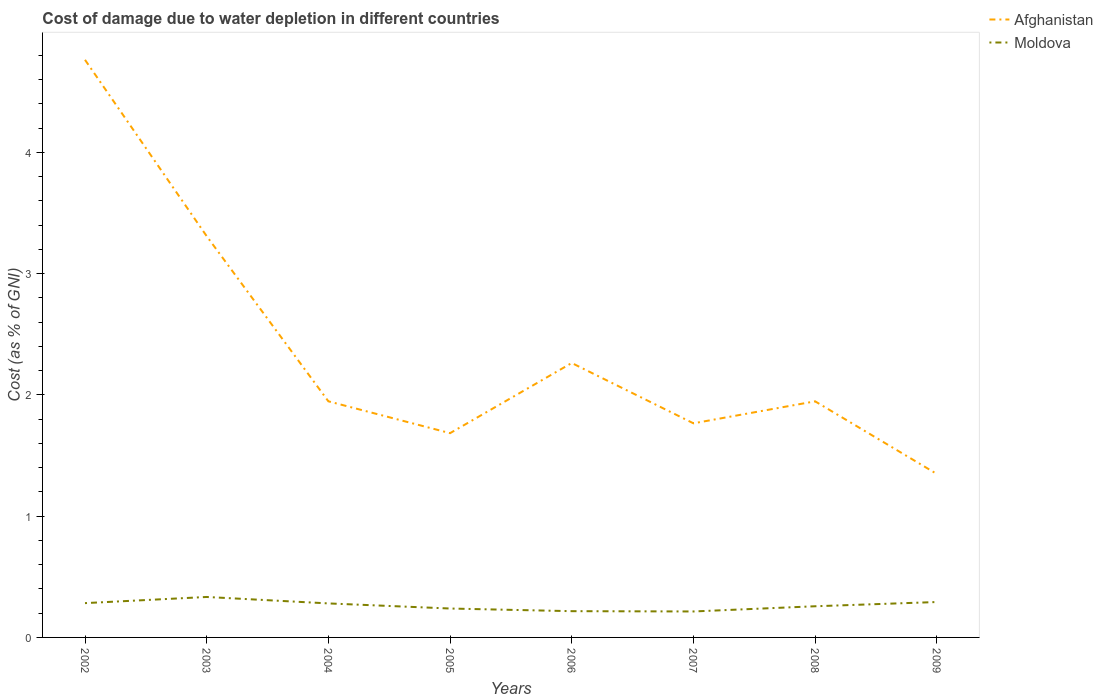Across all years, what is the maximum cost of damage caused due to water depletion in Afghanistan?
Keep it short and to the point. 1.35. What is the total cost of damage caused due to water depletion in Moldova in the graph?
Your answer should be compact. -0.05. What is the difference between the highest and the second highest cost of damage caused due to water depletion in Afghanistan?
Offer a terse response. 3.42. How many years are there in the graph?
Your response must be concise. 8. How many legend labels are there?
Your answer should be compact. 2. How are the legend labels stacked?
Provide a succinct answer. Vertical. What is the title of the graph?
Give a very brief answer. Cost of damage due to water depletion in different countries. Does "Malawi" appear as one of the legend labels in the graph?
Make the answer very short. No. What is the label or title of the Y-axis?
Your answer should be very brief. Cost (as % of GNI). What is the Cost (as % of GNI) of Afghanistan in 2002?
Keep it short and to the point. 4.76. What is the Cost (as % of GNI) in Moldova in 2002?
Offer a very short reply. 0.28. What is the Cost (as % of GNI) of Afghanistan in 2003?
Offer a very short reply. 3.31. What is the Cost (as % of GNI) of Moldova in 2003?
Give a very brief answer. 0.33. What is the Cost (as % of GNI) in Afghanistan in 2004?
Give a very brief answer. 1.95. What is the Cost (as % of GNI) of Moldova in 2004?
Your answer should be compact. 0.28. What is the Cost (as % of GNI) in Afghanistan in 2005?
Your answer should be very brief. 1.68. What is the Cost (as % of GNI) of Moldova in 2005?
Keep it short and to the point. 0.24. What is the Cost (as % of GNI) in Afghanistan in 2006?
Provide a short and direct response. 2.26. What is the Cost (as % of GNI) in Moldova in 2006?
Provide a short and direct response. 0.22. What is the Cost (as % of GNI) of Afghanistan in 2007?
Provide a succinct answer. 1.77. What is the Cost (as % of GNI) of Moldova in 2007?
Ensure brevity in your answer.  0.21. What is the Cost (as % of GNI) in Afghanistan in 2008?
Keep it short and to the point. 1.95. What is the Cost (as % of GNI) in Moldova in 2008?
Offer a very short reply. 0.26. What is the Cost (as % of GNI) of Afghanistan in 2009?
Ensure brevity in your answer.  1.35. What is the Cost (as % of GNI) of Moldova in 2009?
Ensure brevity in your answer.  0.29. Across all years, what is the maximum Cost (as % of GNI) of Afghanistan?
Ensure brevity in your answer.  4.76. Across all years, what is the maximum Cost (as % of GNI) in Moldova?
Ensure brevity in your answer.  0.33. Across all years, what is the minimum Cost (as % of GNI) in Afghanistan?
Give a very brief answer. 1.35. Across all years, what is the minimum Cost (as % of GNI) of Moldova?
Your response must be concise. 0.21. What is the total Cost (as % of GNI) of Afghanistan in the graph?
Make the answer very short. 19.03. What is the total Cost (as % of GNI) of Moldova in the graph?
Make the answer very short. 2.11. What is the difference between the Cost (as % of GNI) of Afghanistan in 2002 and that in 2003?
Make the answer very short. 1.45. What is the difference between the Cost (as % of GNI) in Moldova in 2002 and that in 2003?
Give a very brief answer. -0.05. What is the difference between the Cost (as % of GNI) in Afghanistan in 2002 and that in 2004?
Offer a terse response. 2.82. What is the difference between the Cost (as % of GNI) of Moldova in 2002 and that in 2004?
Provide a short and direct response. 0. What is the difference between the Cost (as % of GNI) of Afghanistan in 2002 and that in 2005?
Provide a short and direct response. 3.08. What is the difference between the Cost (as % of GNI) of Moldova in 2002 and that in 2005?
Ensure brevity in your answer.  0.04. What is the difference between the Cost (as % of GNI) in Afghanistan in 2002 and that in 2006?
Keep it short and to the point. 2.5. What is the difference between the Cost (as % of GNI) in Moldova in 2002 and that in 2006?
Your answer should be compact. 0.07. What is the difference between the Cost (as % of GNI) in Afghanistan in 2002 and that in 2007?
Your answer should be very brief. 3. What is the difference between the Cost (as % of GNI) in Moldova in 2002 and that in 2007?
Provide a short and direct response. 0.07. What is the difference between the Cost (as % of GNI) in Afghanistan in 2002 and that in 2008?
Make the answer very short. 2.82. What is the difference between the Cost (as % of GNI) in Moldova in 2002 and that in 2008?
Offer a very short reply. 0.03. What is the difference between the Cost (as % of GNI) of Afghanistan in 2002 and that in 2009?
Your answer should be compact. 3.42. What is the difference between the Cost (as % of GNI) of Moldova in 2002 and that in 2009?
Provide a short and direct response. -0.01. What is the difference between the Cost (as % of GNI) of Afghanistan in 2003 and that in 2004?
Offer a terse response. 1.36. What is the difference between the Cost (as % of GNI) of Moldova in 2003 and that in 2004?
Your response must be concise. 0.05. What is the difference between the Cost (as % of GNI) of Afghanistan in 2003 and that in 2005?
Your answer should be very brief. 1.62. What is the difference between the Cost (as % of GNI) in Moldova in 2003 and that in 2005?
Your answer should be compact. 0.1. What is the difference between the Cost (as % of GNI) of Afghanistan in 2003 and that in 2006?
Provide a succinct answer. 1.05. What is the difference between the Cost (as % of GNI) of Moldova in 2003 and that in 2006?
Your answer should be very brief. 0.12. What is the difference between the Cost (as % of GNI) of Afghanistan in 2003 and that in 2007?
Offer a terse response. 1.54. What is the difference between the Cost (as % of GNI) in Moldova in 2003 and that in 2007?
Provide a succinct answer. 0.12. What is the difference between the Cost (as % of GNI) in Afghanistan in 2003 and that in 2008?
Keep it short and to the point. 1.36. What is the difference between the Cost (as % of GNI) in Moldova in 2003 and that in 2008?
Your answer should be compact. 0.08. What is the difference between the Cost (as % of GNI) in Afghanistan in 2003 and that in 2009?
Ensure brevity in your answer.  1.96. What is the difference between the Cost (as % of GNI) of Moldova in 2003 and that in 2009?
Offer a terse response. 0.04. What is the difference between the Cost (as % of GNI) of Afghanistan in 2004 and that in 2005?
Keep it short and to the point. 0.26. What is the difference between the Cost (as % of GNI) in Moldova in 2004 and that in 2005?
Your response must be concise. 0.04. What is the difference between the Cost (as % of GNI) in Afghanistan in 2004 and that in 2006?
Keep it short and to the point. -0.32. What is the difference between the Cost (as % of GNI) of Moldova in 2004 and that in 2006?
Provide a short and direct response. 0.06. What is the difference between the Cost (as % of GNI) in Afghanistan in 2004 and that in 2007?
Ensure brevity in your answer.  0.18. What is the difference between the Cost (as % of GNI) of Moldova in 2004 and that in 2007?
Ensure brevity in your answer.  0.07. What is the difference between the Cost (as % of GNI) in Afghanistan in 2004 and that in 2008?
Offer a terse response. 0. What is the difference between the Cost (as % of GNI) of Moldova in 2004 and that in 2008?
Provide a succinct answer. 0.02. What is the difference between the Cost (as % of GNI) in Afghanistan in 2004 and that in 2009?
Give a very brief answer. 0.6. What is the difference between the Cost (as % of GNI) in Moldova in 2004 and that in 2009?
Provide a short and direct response. -0.01. What is the difference between the Cost (as % of GNI) of Afghanistan in 2005 and that in 2006?
Make the answer very short. -0.58. What is the difference between the Cost (as % of GNI) in Moldova in 2005 and that in 2006?
Give a very brief answer. 0.02. What is the difference between the Cost (as % of GNI) of Afghanistan in 2005 and that in 2007?
Provide a short and direct response. -0.08. What is the difference between the Cost (as % of GNI) of Moldova in 2005 and that in 2007?
Keep it short and to the point. 0.02. What is the difference between the Cost (as % of GNI) in Afghanistan in 2005 and that in 2008?
Ensure brevity in your answer.  -0.26. What is the difference between the Cost (as % of GNI) in Moldova in 2005 and that in 2008?
Your answer should be very brief. -0.02. What is the difference between the Cost (as % of GNI) in Afghanistan in 2005 and that in 2009?
Offer a terse response. 0.34. What is the difference between the Cost (as % of GNI) in Moldova in 2005 and that in 2009?
Your answer should be very brief. -0.05. What is the difference between the Cost (as % of GNI) in Afghanistan in 2006 and that in 2007?
Your answer should be compact. 0.5. What is the difference between the Cost (as % of GNI) in Moldova in 2006 and that in 2007?
Your answer should be compact. 0. What is the difference between the Cost (as % of GNI) of Afghanistan in 2006 and that in 2008?
Offer a very short reply. 0.32. What is the difference between the Cost (as % of GNI) in Moldova in 2006 and that in 2008?
Your response must be concise. -0.04. What is the difference between the Cost (as % of GNI) in Afghanistan in 2006 and that in 2009?
Make the answer very short. 0.92. What is the difference between the Cost (as % of GNI) of Moldova in 2006 and that in 2009?
Provide a short and direct response. -0.08. What is the difference between the Cost (as % of GNI) of Afghanistan in 2007 and that in 2008?
Give a very brief answer. -0.18. What is the difference between the Cost (as % of GNI) of Moldova in 2007 and that in 2008?
Your answer should be very brief. -0.04. What is the difference between the Cost (as % of GNI) in Afghanistan in 2007 and that in 2009?
Provide a succinct answer. 0.42. What is the difference between the Cost (as % of GNI) in Moldova in 2007 and that in 2009?
Your answer should be very brief. -0.08. What is the difference between the Cost (as % of GNI) of Afghanistan in 2008 and that in 2009?
Ensure brevity in your answer.  0.6. What is the difference between the Cost (as % of GNI) in Moldova in 2008 and that in 2009?
Your answer should be very brief. -0.03. What is the difference between the Cost (as % of GNI) of Afghanistan in 2002 and the Cost (as % of GNI) of Moldova in 2003?
Ensure brevity in your answer.  4.43. What is the difference between the Cost (as % of GNI) in Afghanistan in 2002 and the Cost (as % of GNI) in Moldova in 2004?
Make the answer very short. 4.48. What is the difference between the Cost (as % of GNI) of Afghanistan in 2002 and the Cost (as % of GNI) of Moldova in 2005?
Keep it short and to the point. 4.52. What is the difference between the Cost (as % of GNI) in Afghanistan in 2002 and the Cost (as % of GNI) in Moldova in 2006?
Provide a succinct answer. 4.55. What is the difference between the Cost (as % of GNI) in Afghanistan in 2002 and the Cost (as % of GNI) in Moldova in 2007?
Provide a succinct answer. 4.55. What is the difference between the Cost (as % of GNI) in Afghanistan in 2002 and the Cost (as % of GNI) in Moldova in 2008?
Keep it short and to the point. 4.51. What is the difference between the Cost (as % of GNI) in Afghanistan in 2002 and the Cost (as % of GNI) in Moldova in 2009?
Offer a very short reply. 4.47. What is the difference between the Cost (as % of GNI) of Afghanistan in 2003 and the Cost (as % of GNI) of Moldova in 2004?
Give a very brief answer. 3.03. What is the difference between the Cost (as % of GNI) of Afghanistan in 2003 and the Cost (as % of GNI) of Moldova in 2005?
Offer a very short reply. 3.07. What is the difference between the Cost (as % of GNI) of Afghanistan in 2003 and the Cost (as % of GNI) of Moldova in 2006?
Your answer should be compact. 3.09. What is the difference between the Cost (as % of GNI) in Afghanistan in 2003 and the Cost (as % of GNI) in Moldova in 2007?
Provide a short and direct response. 3.09. What is the difference between the Cost (as % of GNI) of Afghanistan in 2003 and the Cost (as % of GNI) of Moldova in 2008?
Give a very brief answer. 3.05. What is the difference between the Cost (as % of GNI) of Afghanistan in 2003 and the Cost (as % of GNI) of Moldova in 2009?
Provide a short and direct response. 3.02. What is the difference between the Cost (as % of GNI) of Afghanistan in 2004 and the Cost (as % of GNI) of Moldova in 2005?
Your answer should be compact. 1.71. What is the difference between the Cost (as % of GNI) in Afghanistan in 2004 and the Cost (as % of GNI) in Moldova in 2006?
Keep it short and to the point. 1.73. What is the difference between the Cost (as % of GNI) in Afghanistan in 2004 and the Cost (as % of GNI) in Moldova in 2007?
Your response must be concise. 1.73. What is the difference between the Cost (as % of GNI) of Afghanistan in 2004 and the Cost (as % of GNI) of Moldova in 2008?
Your response must be concise. 1.69. What is the difference between the Cost (as % of GNI) in Afghanistan in 2004 and the Cost (as % of GNI) in Moldova in 2009?
Give a very brief answer. 1.66. What is the difference between the Cost (as % of GNI) of Afghanistan in 2005 and the Cost (as % of GNI) of Moldova in 2006?
Your answer should be compact. 1.47. What is the difference between the Cost (as % of GNI) in Afghanistan in 2005 and the Cost (as % of GNI) in Moldova in 2007?
Provide a short and direct response. 1.47. What is the difference between the Cost (as % of GNI) in Afghanistan in 2005 and the Cost (as % of GNI) in Moldova in 2008?
Offer a very short reply. 1.43. What is the difference between the Cost (as % of GNI) in Afghanistan in 2005 and the Cost (as % of GNI) in Moldova in 2009?
Provide a short and direct response. 1.39. What is the difference between the Cost (as % of GNI) of Afghanistan in 2006 and the Cost (as % of GNI) of Moldova in 2007?
Make the answer very short. 2.05. What is the difference between the Cost (as % of GNI) of Afghanistan in 2006 and the Cost (as % of GNI) of Moldova in 2008?
Make the answer very short. 2.01. What is the difference between the Cost (as % of GNI) of Afghanistan in 2006 and the Cost (as % of GNI) of Moldova in 2009?
Provide a succinct answer. 1.97. What is the difference between the Cost (as % of GNI) of Afghanistan in 2007 and the Cost (as % of GNI) of Moldova in 2008?
Your response must be concise. 1.51. What is the difference between the Cost (as % of GNI) of Afghanistan in 2007 and the Cost (as % of GNI) of Moldova in 2009?
Your answer should be compact. 1.47. What is the difference between the Cost (as % of GNI) of Afghanistan in 2008 and the Cost (as % of GNI) of Moldova in 2009?
Ensure brevity in your answer.  1.66. What is the average Cost (as % of GNI) in Afghanistan per year?
Make the answer very short. 2.38. What is the average Cost (as % of GNI) in Moldova per year?
Provide a succinct answer. 0.26. In the year 2002, what is the difference between the Cost (as % of GNI) in Afghanistan and Cost (as % of GNI) in Moldova?
Your answer should be compact. 4.48. In the year 2003, what is the difference between the Cost (as % of GNI) in Afghanistan and Cost (as % of GNI) in Moldova?
Your answer should be very brief. 2.98. In the year 2004, what is the difference between the Cost (as % of GNI) of Afghanistan and Cost (as % of GNI) of Moldova?
Your answer should be very brief. 1.67. In the year 2005, what is the difference between the Cost (as % of GNI) of Afghanistan and Cost (as % of GNI) of Moldova?
Ensure brevity in your answer.  1.45. In the year 2006, what is the difference between the Cost (as % of GNI) of Afghanistan and Cost (as % of GNI) of Moldova?
Your answer should be compact. 2.05. In the year 2007, what is the difference between the Cost (as % of GNI) in Afghanistan and Cost (as % of GNI) in Moldova?
Keep it short and to the point. 1.55. In the year 2008, what is the difference between the Cost (as % of GNI) of Afghanistan and Cost (as % of GNI) of Moldova?
Your answer should be compact. 1.69. In the year 2009, what is the difference between the Cost (as % of GNI) of Afghanistan and Cost (as % of GNI) of Moldova?
Keep it short and to the point. 1.06. What is the ratio of the Cost (as % of GNI) of Afghanistan in 2002 to that in 2003?
Provide a short and direct response. 1.44. What is the ratio of the Cost (as % of GNI) of Moldova in 2002 to that in 2003?
Your response must be concise. 0.85. What is the ratio of the Cost (as % of GNI) of Afghanistan in 2002 to that in 2004?
Offer a very short reply. 2.45. What is the ratio of the Cost (as % of GNI) in Moldova in 2002 to that in 2004?
Ensure brevity in your answer.  1.01. What is the ratio of the Cost (as % of GNI) in Afghanistan in 2002 to that in 2005?
Offer a terse response. 2.83. What is the ratio of the Cost (as % of GNI) of Moldova in 2002 to that in 2005?
Your answer should be very brief. 1.19. What is the ratio of the Cost (as % of GNI) in Afghanistan in 2002 to that in 2006?
Keep it short and to the point. 2.1. What is the ratio of the Cost (as % of GNI) of Moldova in 2002 to that in 2006?
Your response must be concise. 1.31. What is the ratio of the Cost (as % of GNI) of Afghanistan in 2002 to that in 2007?
Provide a succinct answer. 2.7. What is the ratio of the Cost (as % of GNI) in Moldova in 2002 to that in 2007?
Keep it short and to the point. 1.32. What is the ratio of the Cost (as % of GNI) of Afghanistan in 2002 to that in 2008?
Your response must be concise. 2.45. What is the ratio of the Cost (as % of GNI) of Moldova in 2002 to that in 2008?
Provide a short and direct response. 1.1. What is the ratio of the Cost (as % of GNI) in Afghanistan in 2002 to that in 2009?
Give a very brief answer. 3.53. What is the ratio of the Cost (as % of GNI) in Moldova in 2002 to that in 2009?
Offer a terse response. 0.97. What is the ratio of the Cost (as % of GNI) in Afghanistan in 2003 to that in 2004?
Provide a short and direct response. 1.7. What is the ratio of the Cost (as % of GNI) in Moldova in 2003 to that in 2004?
Ensure brevity in your answer.  1.19. What is the ratio of the Cost (as % of GNI) in Afghanistan in 2003 to that in 2005?
Provide a short and direct response. 1.96. What is the ratio of the Cost (as % of GNI) in Moldova in 2003 to that in 2005?
Ensure brevity in your answer.  1.4. What is the ratio of the Cost (as % of GNI) in Afghanistan in 2003 to that in 2006?
Make the answer very short. 1.46. What is the ratio of the Cost (as % of GNI) of Moldova in 2003 to that in 2006?
Offer a terse response. 1.54. What is the ratio of the Cost (as % of GNI) of Afghanistan in 2003 to that in 2007?
Ensure brevity in your answer.  1.87. What is the ratio of the Cost (as % of GNI) of Moldova in 2003 to that in 2007?
Your answer should be compact. 1.56. What is the ratio of the Cost (as % of GNI) of Afghanistan in 2003 to that in 2008?
Offer a terse response. 1.7. What is the ratio of the Cost (as % of GNI) in Moldova in 2003 to that in 2008?
Provide a short and direct response. 1.3. What is the ratio of the Cost (as % of GNI) in Afghanistan in 2003 to that in 2009?
Provide a succinct answer. 2.45. What is the ratio of the Cost (as % of GNI) of Moldova in 2003 to that in 2009?
Provide a short and direct response. 1.14. What is the ratio of the Cost (as % of GNI) in Afghanistan in 2004 to that in 2005?
Keep it short and to the point. 1.16. What is the ratio of the Cost (as % of GNI) in Moldova in 2004 to that in 2005?
Ensure brevity in your answer.  1.18. What is the ratio of the Cost (as % of GNI) of Afghanistan in 2004 to that in 2006?
Your answer should be compact. 0.86. What is the ratio of the Cost (as % of GNI) of Moldova in 2004 to that in 2006?
Your response must be concise. 1.3. What is the ratio of the Cost (as % of GNI) of Afghanistan in 2004 to that in 2007?
Give a very brief answer. 1.1. What is the ratio of the Cost (as % of GNI) in Moldova in 2004 to that in 2007?
Provide a short and direct response. 1.31. What is the ratio of the Cost (as % of GNI) in Moldova in 2004 to that in 2008?
Your answer should be very brief. 1.09. What is the ratio of the Cost (as % of GNI) in Afghanistan in 2004 to that in 2009?
Offer a terse response. 1.44. What is the ratio of the Cost (as % of GNI) in Moldova in 2004 to that in 2009?
Ensure brevity in your answer.  0.96. What is the ratio of the Cost (as % of GNI) in Afghanistan in 2005 to that in 2006?
Your response must be concise. 0.74. What is the ratio of the Cost (as % of GNI) in Moldova in 2005 to that in 2006?
Provide a short and direct response. 1.1. What is the ratio of the Cost (as % of GNI) of Afghanistan in 2005 to that in 2007?
Make the answer very short. 0.95. What is the ratio of the Cost (as % of GNI) of Moldova in 2005 to that in 2007?
Offer a terse response. 1.11. What is the ratio of the Cost (as % of GNI) of Afghanistan in 2005 to that in 2008?
Provide a succinct answer. 0.87. What is the ratio of the Cost (as % of GNI) of Moldova in 2005 to that in 2008?
Make the answer very short. 0.93. What is the ratio of the Cost (as % of GNI) of Afghanistan in 2005 to that in 2009?
Offer a very short reply. 1.25. What is the ratio of the Cost (as % of GNI) of Moldova in 2005 to that in 2009?
Provide a succinct answer. 0.82. What is the ratio of the Cost (as % of GNI) in Afghanistan in 2006 to that in 2007?
Your answer should be compact. 1.28. What is the ratio of the Cost (as % of GNI) of Moldova in 2006 to that in 2007?
Provide a succinct answer. 1.01. What is the ratio of the Cost (as % of GNI) of Afghanistan in 2006 to that in 2008?
Give a very brief answer. 1.16. What is the ratio of the Cost (as % of GNI) in Moldova in 2006 to that in 2008?
Make the answer very short. 0.84. What is the ratio of the Cost (as % of GNI) in Afghanistan in 2006 to that in 2009?
Your response must be concise. 1.68. What is the ratio of the Cost (as % of GNI) of Moldova in 2006 to that in 2009?
Your answer should be very brief. 0.74. What is the ratio of the Cost (as % of GNI) in Afghanistan in 2007 to that in 2008?
Offer a terse response. 0.91. What is the ratio of the Cost (as % of GNI) of Moldova in 2007 to that in 2008?
Ensure brevity in your answer.  0.83. What is the ratio of the Cost (as % of GNI) in Afghanistan in 2007 to that in 2009?
Your answer should be compact. 1.31. What is the ratio of the Cost (as % of GNI) of Moldova in 2007 to that in 2009?
Your answer should be very brief. 0.73. What is the ratio of the Cost (as % of GNI) of Afghanistan in 2008 to that in 2009?
Your response must be concise. 1.44. What is the ratio of the Cost (as % of GNI) in Moldova in 2008 to that in 2009?
Your answer should be very brief. 0.88. What is the difference between the highest and the second highest Cost (as % of GNI) of Afghanistan?
Make the answer very short. 1.45. What is the difference between the highest and the second highest Cost (as % of GNI) of Moldova?
Provide a succinct answer. 0.04. What is the difference between the highest and the lowest Cost (as % of GNI) of Afghanistan?
Your response must be concise. 3.42. What is the difference between the highest and the lowest Cost (as % of GNI) of Moldova?
Offer a very short reply. 0.12. 